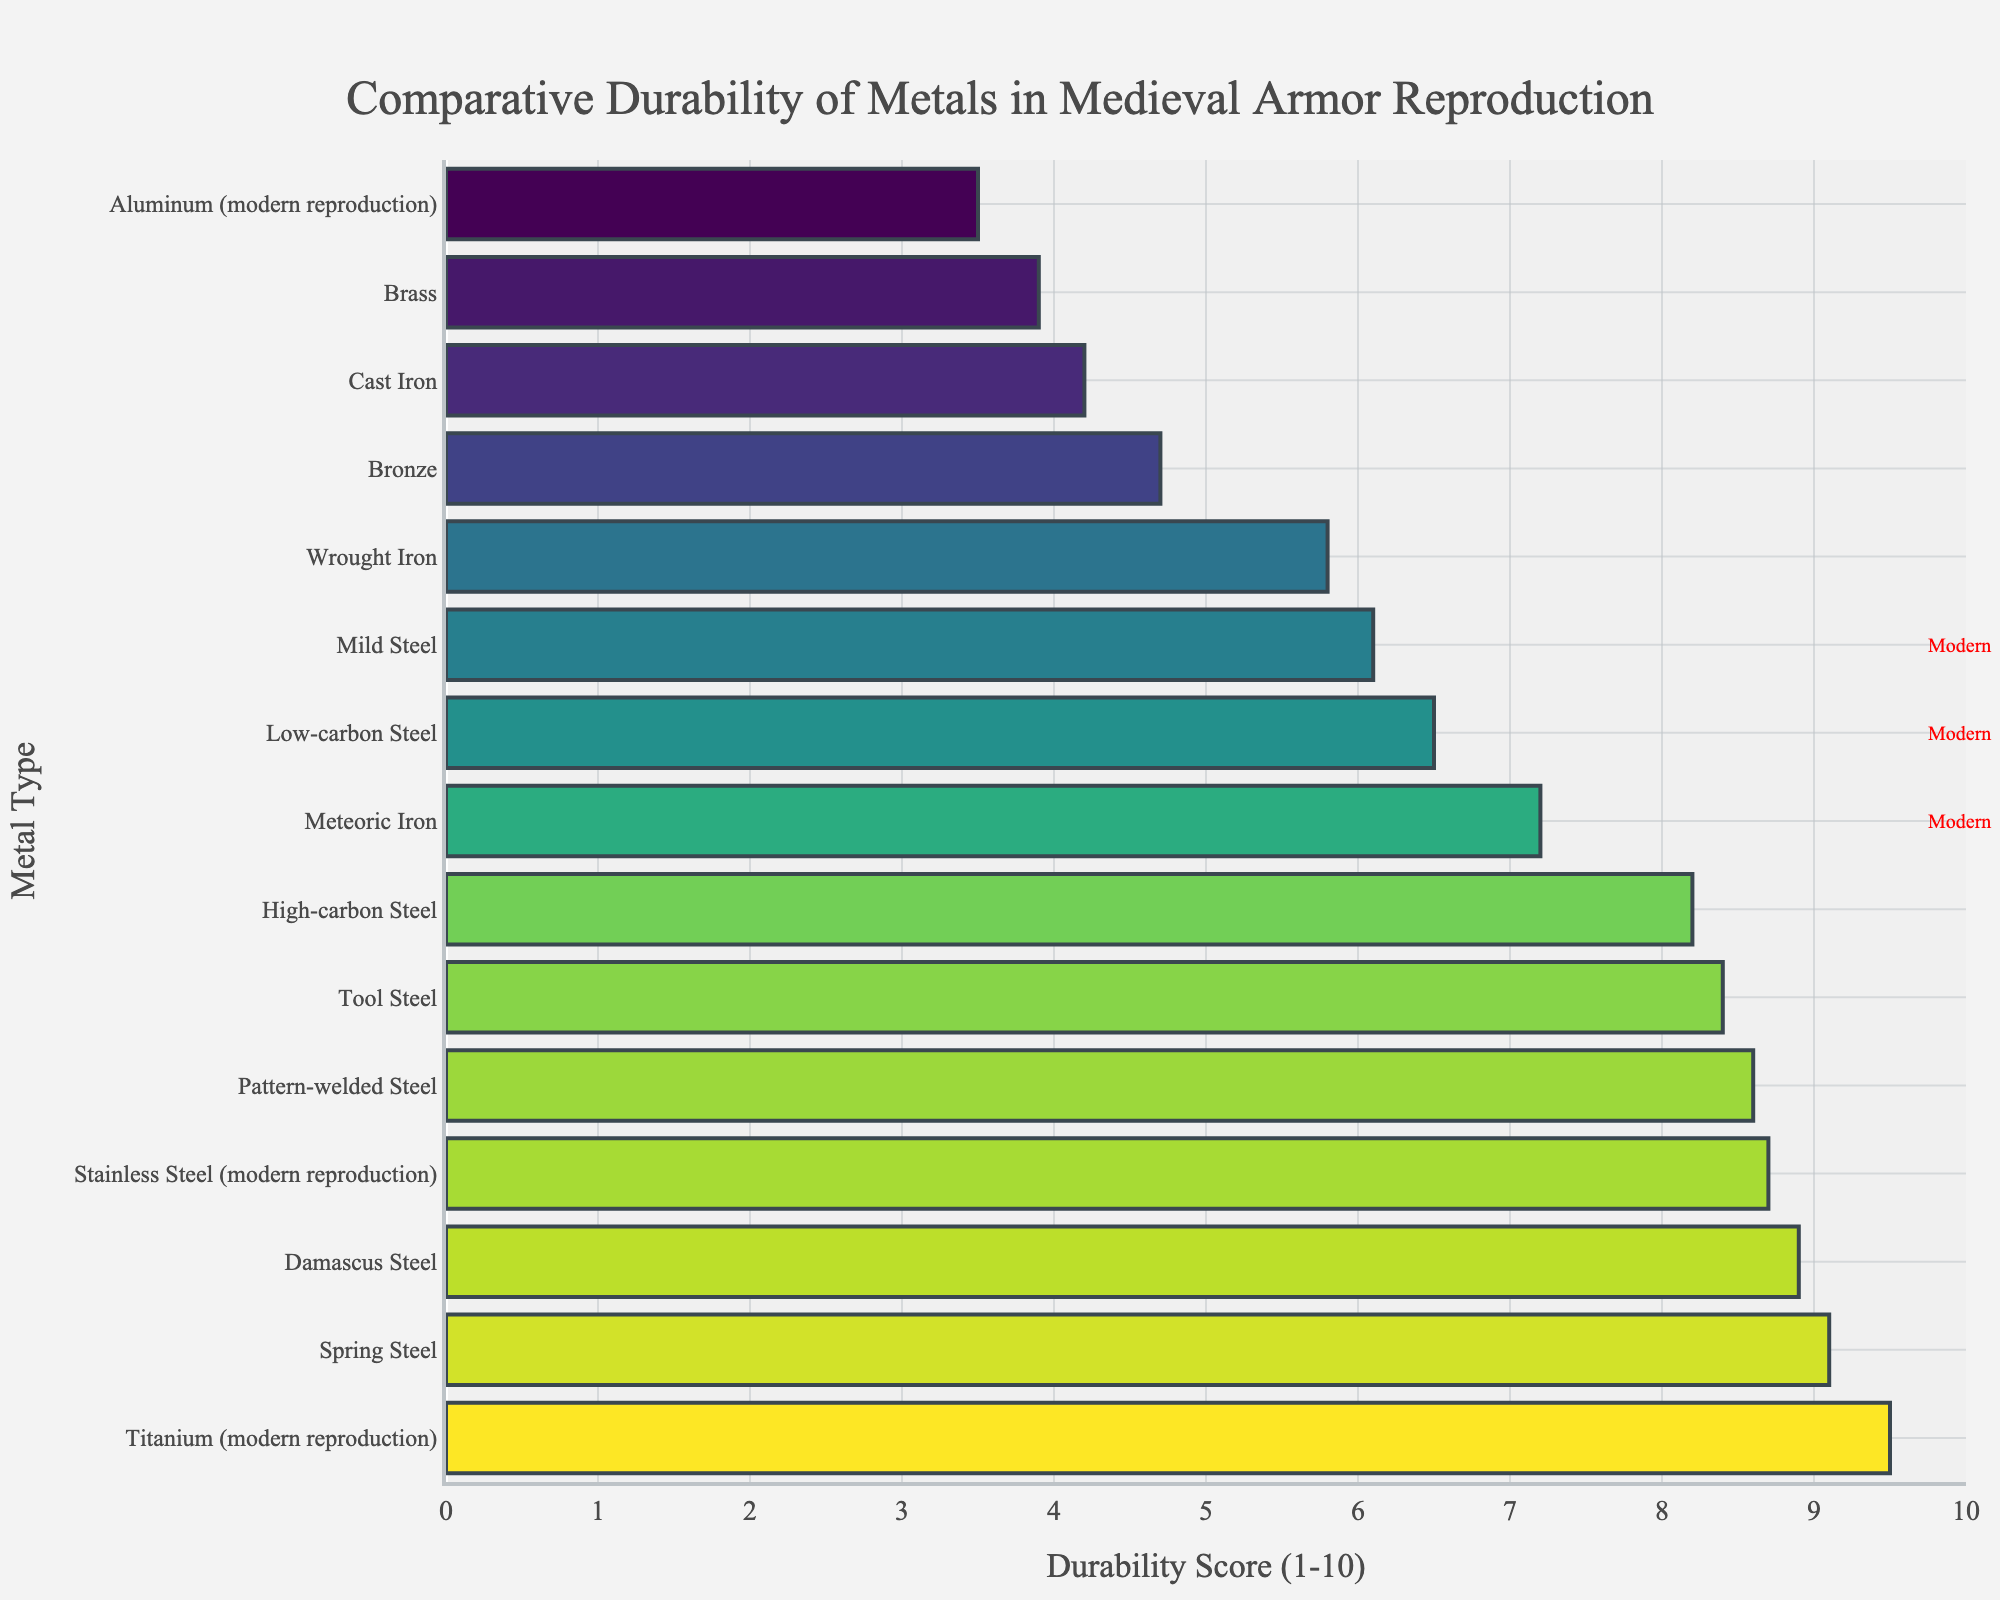What's the most durable metal used in medieval armor reproduction? The figure shows a bar chart with the comparative durability of various metals. By observing the chart, the metal with the highest durability score is titanium (modern reproduction) with a score of 9.5.
Answer: Titanium (modern reproduction) Which metal in the chart has the lowest durability score? We need to find the shortest bar in the chart since each bar represents the durability score. Aluminum (modern reproduction) has the lowest score of 3.5.
Answer: Aluminum (modern reproduction) How does the durability of low-carbon steel compare to high-carbon steel? We look for the bars representing low-carbon steel and high-carbon steel and compare their lengths. Low-carbon steel has a durability score of 6.5, while high-carbon steel has a score of 8.2.
Answer: High-carbon Steel is more durable than Low-carbon Steel What is the average durability score of all metals listed in the chart? To find the average, we sum all the durability scores and divide by the number of metals:
(6.5 + 8.2 + 9.1 + 5.8 + 4.2 + 4.7 + 3.9 + 9.5 + 8.7 + 3.5 + 6.1 + 8.4 + 8.9 + 8.6 + 7.2) / 15 = 6.68
Answer: 6.68 How many metals have a durability score higher than 8? Identify the bars with scores greater than 8: High-carbon Steel (8.2), Spring Steel (9.1), Titanium (modern reproduction) (9.5), Stainless Steel (modern reproduction) (8.7), Tool Steel (8.4), Damascus Steel (8.9), and Pattern-welded Steel (8.6). There are 7 such metals.
Answer: 7 Among the historical metals, which one is the most durable? Exclude modern reproductions and find the longest bar among the historical metal bars. Spring Steel has the highest durability among historical metals with a score of 9.1.
Answer: Spring Steel Which metal has a durability score closest to 5? Locate the bar that is closest to the score of 5. Wrought Iron has a score of 5.8, which is the closest to 5.
Answer: Wrought Iron Compare the average durability of modern reproductions to historical metals. Calculate the average for modern reproductions (Titanium, Stainless Steel, Aluminum): (9.5 + 8.7 + 3.5) / 3 = 7.23. For historical metals: (6.5 + 8.2 + 9.1 + 5.8 + 4.2 + 4.7 + 3.9 + 6.1 + 8.4 + 8.9 + 8.6 + 7.2) / 12 = 6.62.
Answer: Modern reproductions have a higher average durability (7.23) compared to historical metals (6.62) Identify which metals appear with modern reproduction tags in the chart. Based on the annotations, the metals tagged as modern reproductions are Titanium (9.5), Stainless Steel (8.7), and Aluminum (3.5).
Answer: Titanium, Stainless Steel, Aluminum 